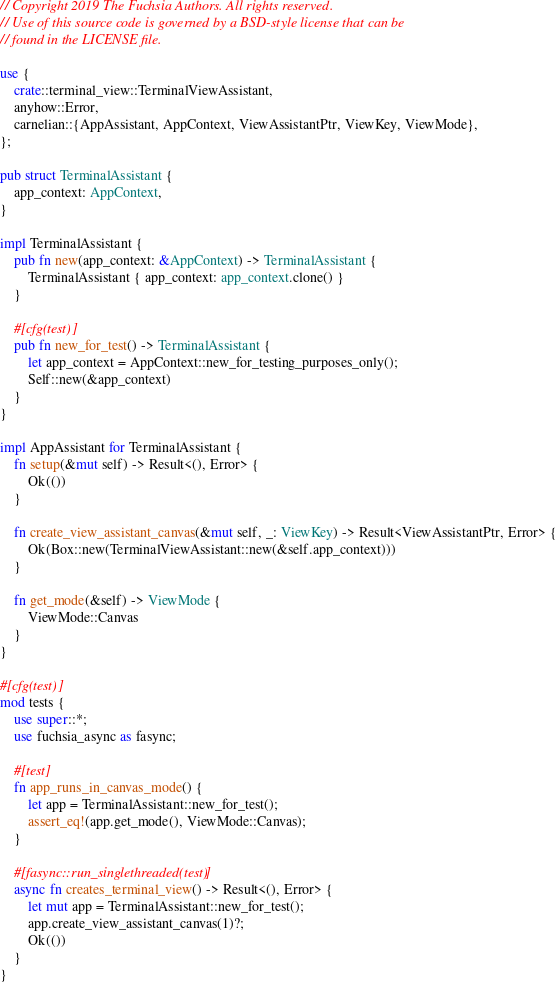<code> <loc_0><loc_0><loc_500><loc_500><_Rust_>// Copyright 2019 The Fuchsia Authors. All rights reserved.
// Use of this source code is governed by a BSD-style license that can be
// found in the LICENSE file.

use {
    crate::terminal_view::TerminalViewAssistant,
    anyhow::Error,
    carnelian::{AppAssistant, AppContext, ViewAssistantPtr, ViewKey, ViewMode},
};

pub struct TerminalAssistant {
    app_context: AppContext,
}

impl TerminalAssistant {
    pub fn new(app_context: &AppContext) -> TerminalAssistant {
        TerminalAssistant { app_context: app_context.clone() }
    }

    #[cfg(test)]
    pub fn new_for_test() -> TerminalAssistant {
        let app_context = AppContext::new_for_testing_purposes_only();
        Self::new(&app_context)
    }
}

impl AppAssistant for TerminalAssistant {
    fn setup(&mut self) -> Result<(), Error> {
        Ok(())
    }

    fn create_view_assistant_canvas(&mut self, _: ViewKey) -> Result<ViewAssistantPtr, Error> {
        Ok(Box::new(TerminalViewAssistant::new(&self.app_context)))
    }

    fn get_mode(&self) -> ViewMode {
        ViewMode::Canvas
    }
}

#[cfg(test)]
mod tests {
    use super::*;
    use fuchsia_async as fasync;

    #[test]
    fn app_runs_in_canvas_mode() {
        let app = TerminalAssistant::new_for_test();
        assert_eq!(app.get_mode(), ViewMode::Canvas);
    }

    #[fasync::run_singlethreaded(test)]
    async fn creates_terminal_view() -> Result<(), Error> {
        let mut app = TerminalAssistant::new_for_test();
        app.create_view_assistant_canvas(1)?;
        Ok(())
    }
}
</code> 